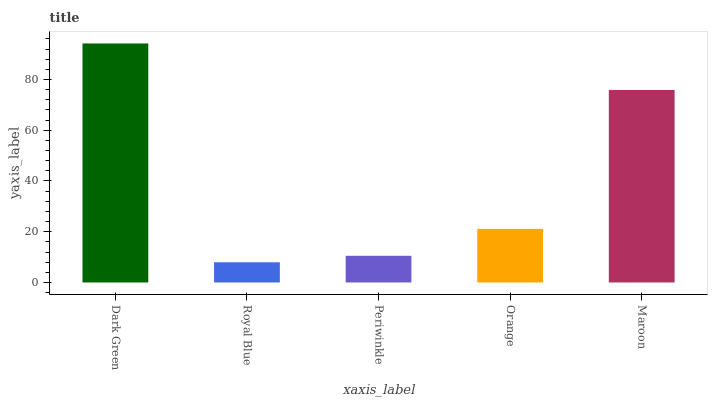Is Royal Blue the minimum?
Answer yes or no. Yes. Is Dark Green the maximum?
Answer yes or no. Yes. Is Periwinkle the minimum?
Answer yes or no. No. Is Periwinkle the maximum?
Answer yes or no. No. Is Periwinkle greater than Royal Blue?
Answer yes or no. Yes. Is Royal Blue less than Periwinkle?
Answer yes or no. Yes. Is Royal Blue greater than Periwinkle?
Answer yes or no. No. Is Periwinkle less than Royal Blue?
Answer yes or no. No. Is Orange the high median?
Answer yes or no. Yes. Is Orange the low median?
Answer yes or no. Yes. Is Royal Blue the high median?
Answer yes or no. No. Is Maroon the low median?
Answer yes or no. No. 